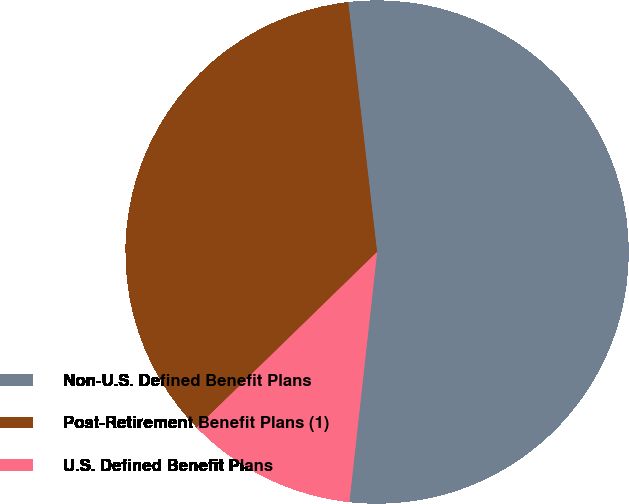Convert chart to OTSL. <chart><loc_0><loc_0><loc_500><loc_500><pie_chart><fcel>Non-U.S. Defined Benefit Plans<fcel>Post-Retirement Benefit Plans (1)<fcel>U.S. Defined Benefit Plans<nl><fcel>53.59%<fcel>35.45%<fcel>10.96%<nl></chart> 